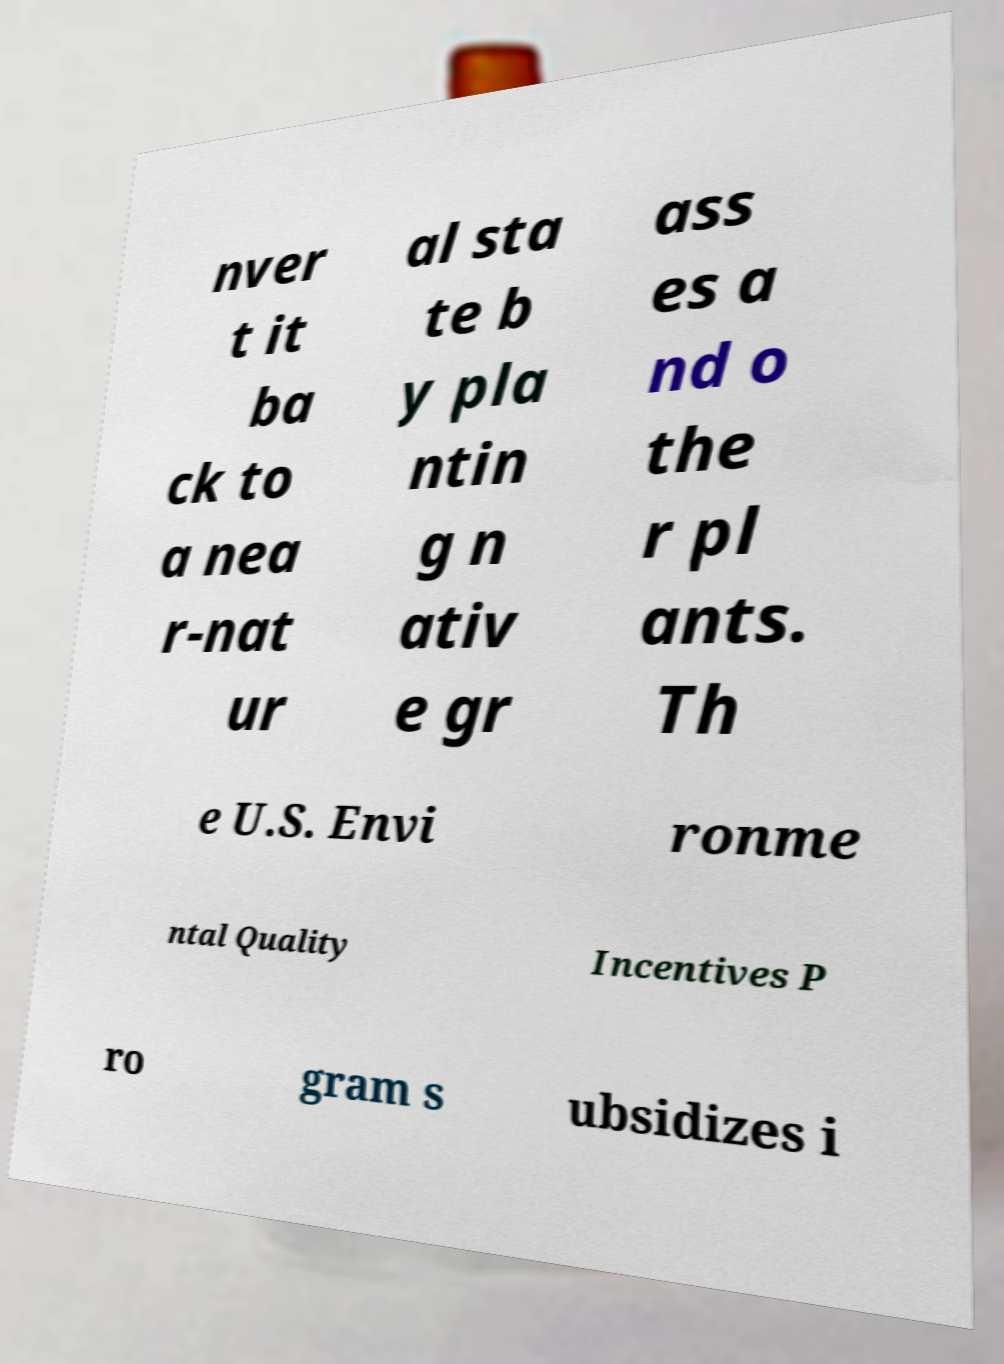There's text embedded in this image that I need extracted. Can you transcribe it verbatim? nver t it ba ck to a nea r-nat ur al sta te b y pla ntin g n ativ e gr ass es a nd o the r pl ants. Th e U.S. Envi ronme ntal Quality Incentives P ro gram s ubsidizes i 